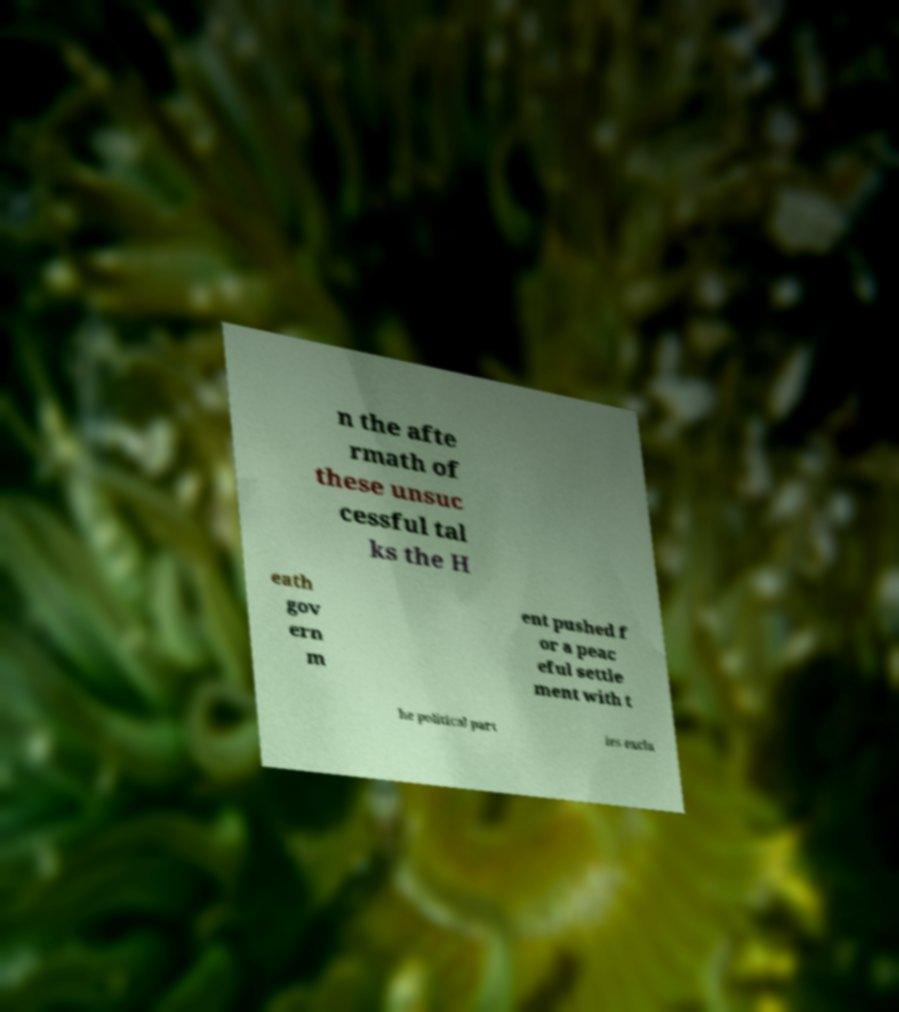I need the written content from this picture converted into text. Can you do that? n the afte rmath of these unsuc cessful tal ks the H eath gov ern m ent pushed f or a peac eful settle ment with t he political part ies exclu 